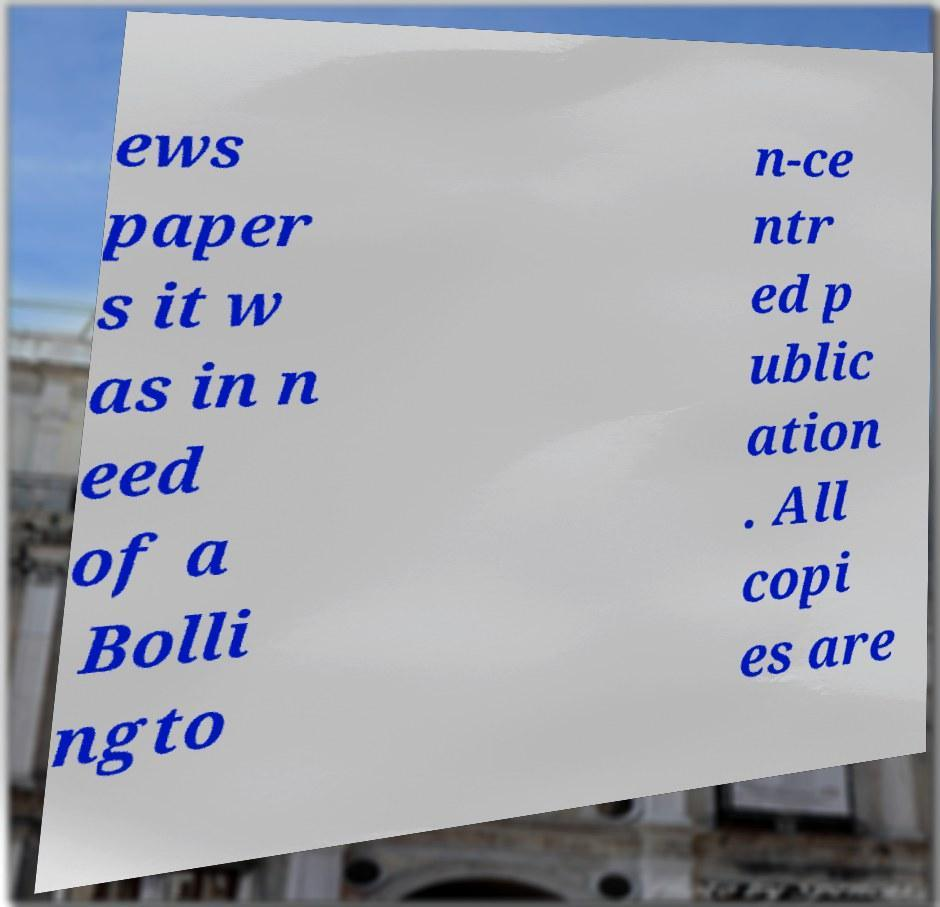There's text embedded in this image that I need extracted. Can you transcribe it verbatim? ews paper s it w as in n eed of a Bolli ngto n-ce ntr ed p ublic ation . All copi es are 